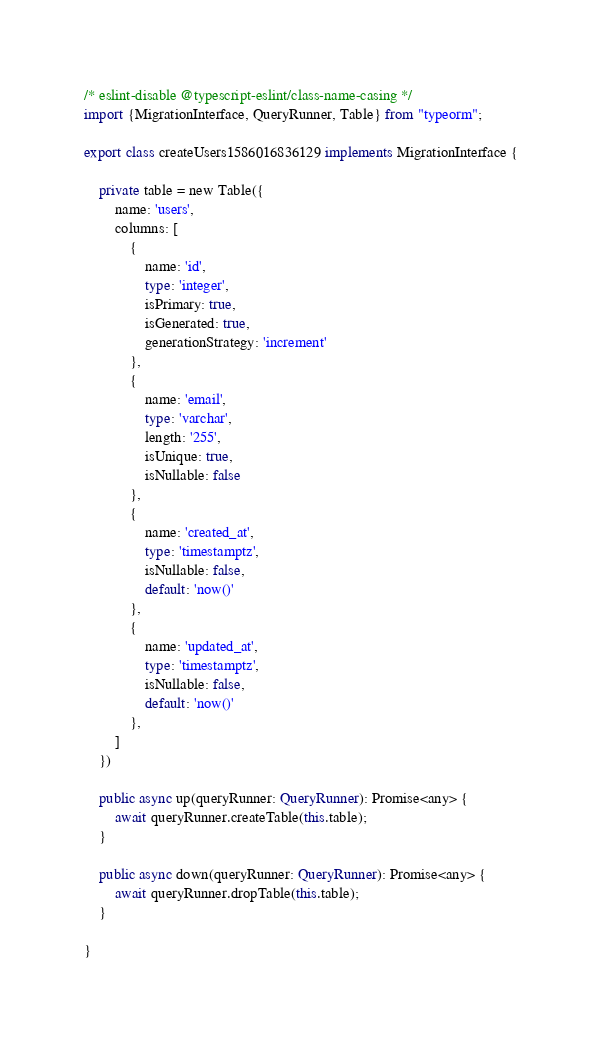Convert code to text. <code><loc_0><loc_0><loc_500><loc_500><_TypeScript_>/* eslint-disable @typescript-eslint/class-name-casing */
import {MigrationInterface, QueryRunner, Table} from "typeorm";

export class createUsers1586016836129 implements MigrationInterface {

    private table = new Table({
        name: 'users',
        columns: [
            {
                name: 'id',
                type: 'integer',
                isPrimary: true,
                isGenerated: true,
                generationStrategy: 'increment'
            },
            {
                name: 'email',
                type: 'varchar',
                length: '255',
                isUnique: true,
                isNullable: false
            },
            {
                name: 'created_at',
                type: 'timestamptz',
                isNullable: false,
                default: 'now()'
            },
            {
                name: 'updated_at',
                type: 'timestamptz',
                isNullable: false,
                default: 'now()'
            },
        ]
    })

    public async up(queryRunner: QueryRunner): Promise<any> {
        await queryRunner.createTable(this.table);
    }

    public async down(queryRunner: QueryRunner): Promise<any> {
        await queryRunner.dropTable(this.table);
    }

}
</code> 